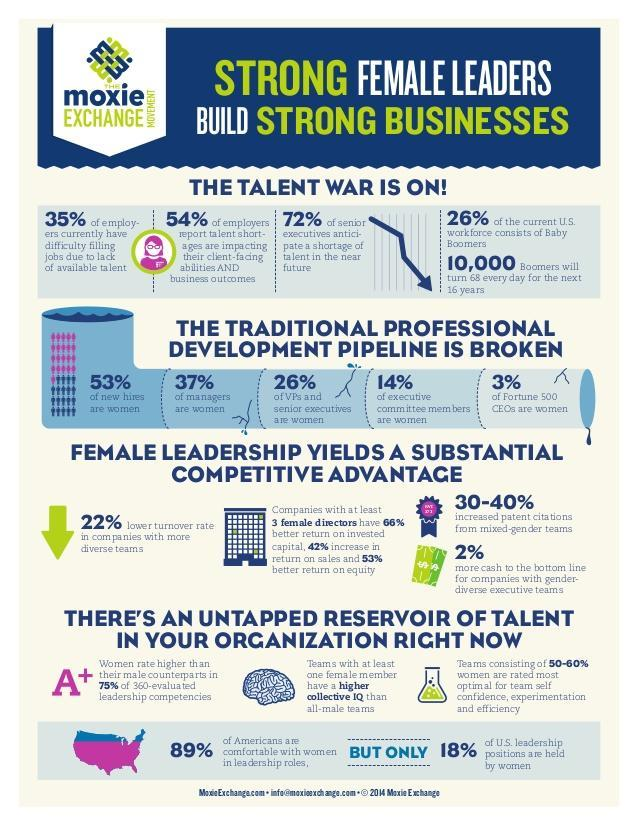What percentage of US leadership positions are not held by women?
Answer the question with a short phrase. 82% What percentage of new hires are not women? 47% What percentage of executive committee members are not women? 86% What percentage of VPs and senior executives are not women? 74% What percentage of Fortune 500 CEOs are not women? 97% What percentage of Americans are not comfortable with women in leadership roles? 11% What percentage of managers are not women? 63% 